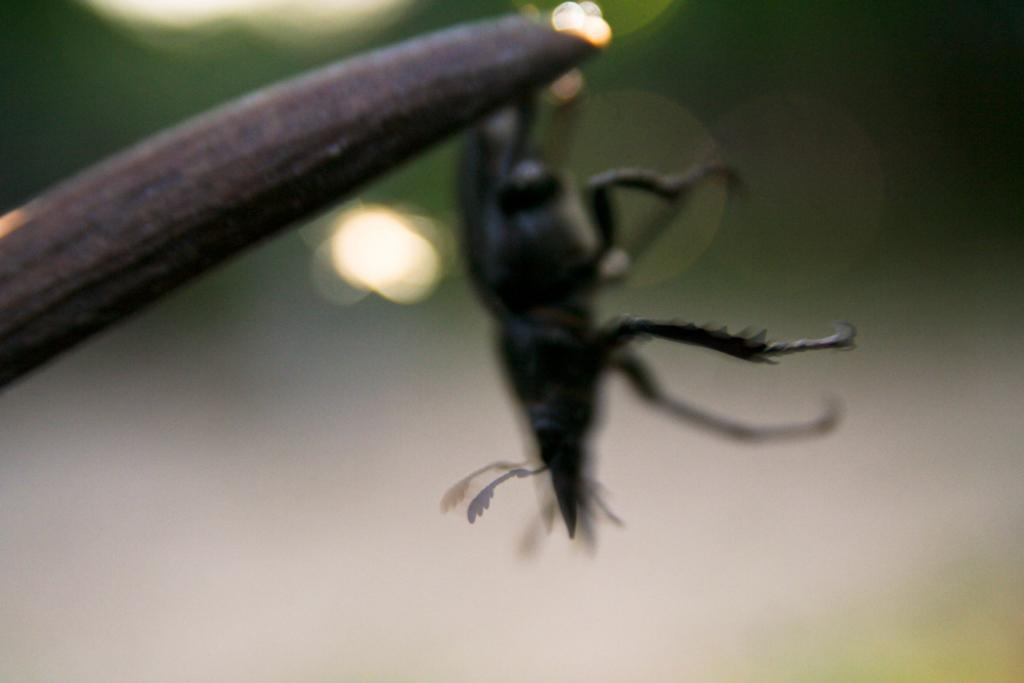What is the main subject of the picture? The main subject of the picture is an insect. Can you describe the insect's appearance? The insect is black in color. Where is the insect located in the picture? The insect is in the middle of the picture. How would you describe the background of the image? The background of the image is blurred. What type of can is visible in the picture? There is no can present in the image; it features an insect. Can you describe the exchange between the insect and the holiday decoration in the picture? There is no holiday decoration present in the image, and the insect is not engaged in any exchange. 